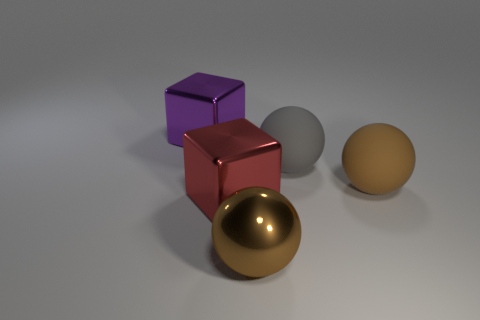What material is the other big ball that is the same color as the large metallic sphere?
Give a very brief answer. Rubber. There is a block on the right side of the shiny object behind the big red metallic cube; what is its color?
Your answer should be very brief. Red. There is a red object that is in front of the block behind the large metallic block that is on the right side of the purple metallic cube; what is its shape?
Keep it short and to the point. Cube. How many large brown things have the same material as the purple thing?
Provide a succinct answer. 1. There is a brown object that is right of the big brown metallic sphere; what number of big metallic things are behind it?
Offer a very short reply. 1. What number of purple blocks are there?
Give a very brief answer. 1. Is the material of the gray ball the same as the brown ball that is left of the big brown rubber ball?
Offer a very short reply. No. Is the color of the shiny block in front of the purple block the same as the shiny sphere?
Your answer should be compact. No. What is the material of the big ball that is both in front of the big gray sphere and behind the large shiny ball?
Your answer should be compact. Rubber. What is the size of the gray sphere?
Keep it short and to the point. Large. 